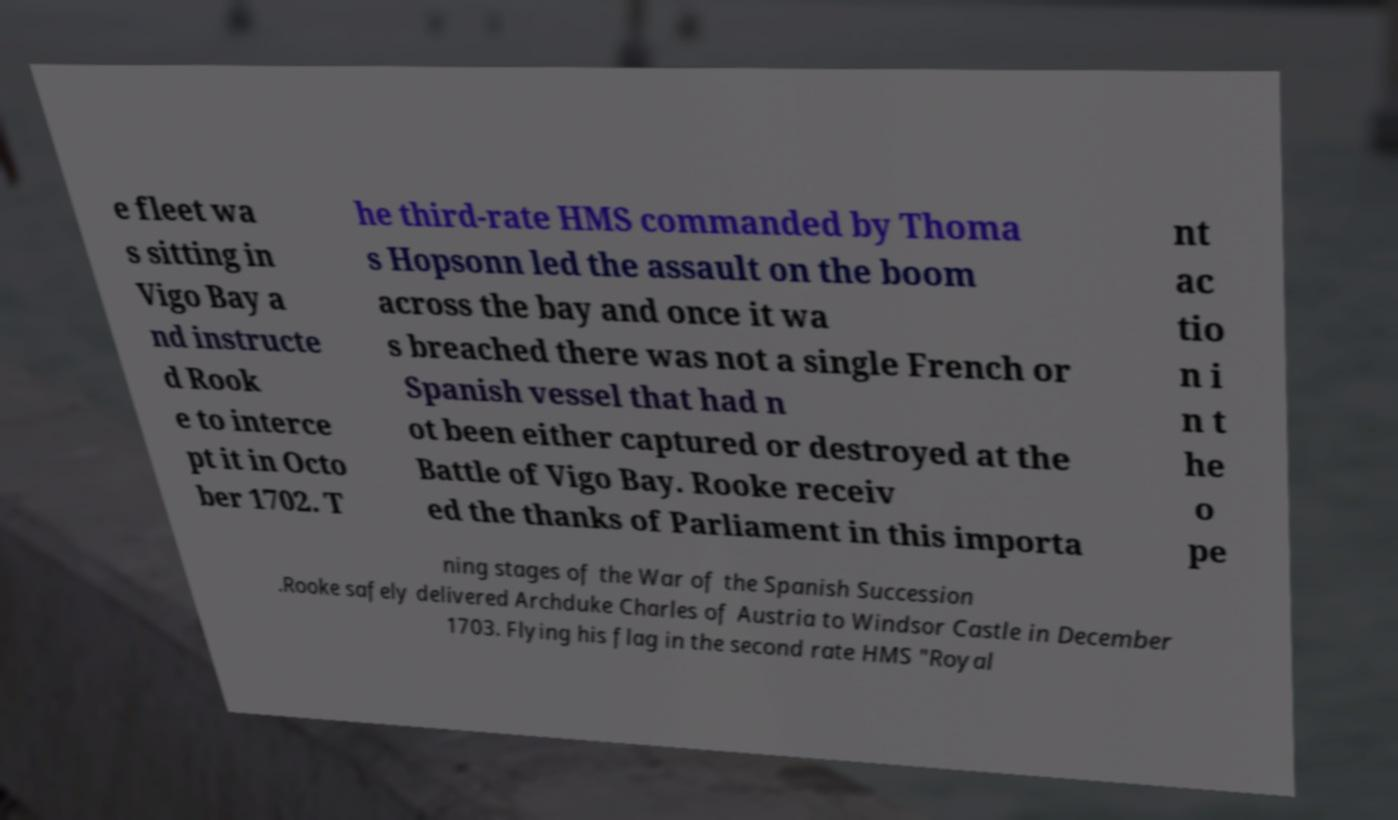Can you read and provide the text displayed in the image?This photo seems to have some interesting text. Can you extract and type it out for me? e fleet wa s sitting in Vigo Bay a nd instructe d Rook e to interce pt it in Octo ber 1702. T he third-rate HMS commanded by Thoma s Hopsonn led the assault on the boom across the bay and once it wa s breached there was not a single French or Spanish vessel that had n ot been either captured or destroyed at the Battle of Vigo Bay. Rooke receiv ed the thanks of Parliament in this importa nt ac tio n i n t he o pe ning stages of the War of the Spanish Succession .Rooke safely delivered Archduke Charles of Austria to Windsor Castle in December 1703. Flying his flag in the second rate HMS "Royal 